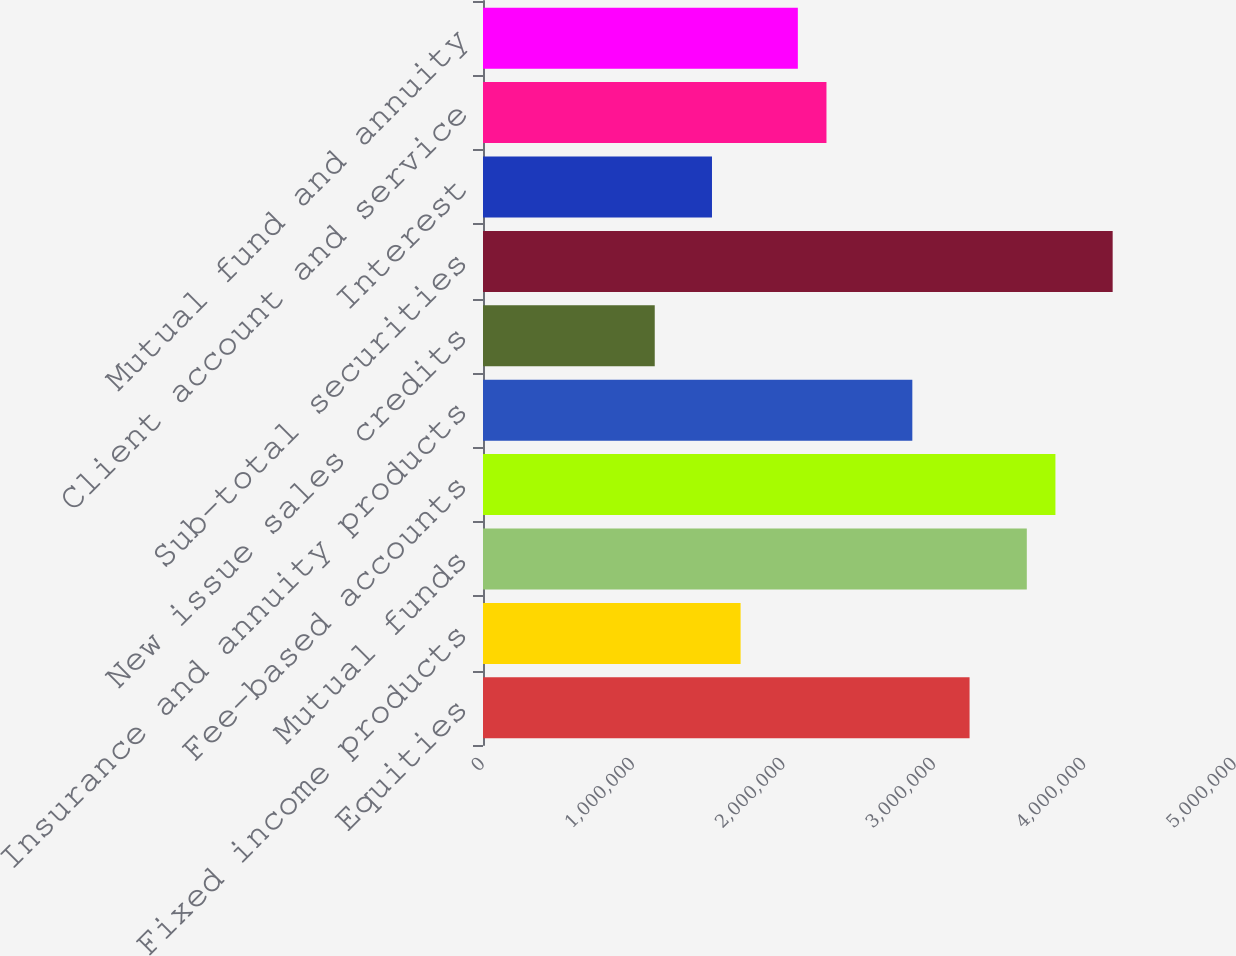Convert chart to OTSL. <chart><loc_0><loc_0><loc_500><loc_500><bar_chart><fcel>Equities<fcel>Fixed income products<fcel>Mutual funds<fcel>Fee-based accounts<fcel>Insurance and annuity products<fcel>New issue sales credits<fcel>Sub-total securities<fcel>Interest<fcel>Client account and service<fcel>Mutual fund and annuity<nl><fcel>3.23515e+06<fcel>1.71281e+06<fcel>3.61574e+06<fcel>3.80603e+06<fcel>2.85457e+06<fcel>1.14193e+06<fcel>4.18662e+06<fcel>1.52251e+06<fcel>2.28369e+06<fcel>2.09339e+06<nl></chart> 